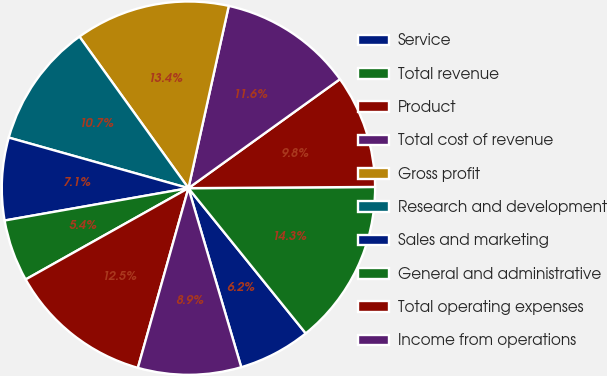Convert chart. <chart><loc_0><loc_0><loc_500><loc_500><pie_chart><fcel>Service<fcel>Total revenue<fcel>Product<fcel>Total cost of revenue<fcel>Gross profit<fcel>Research and development<fcel>Sales and marketing<fcel>General and administrative<fcel>Total operating expenses<fcel>Income from operations<nl><fcel>6.25%<fcel>14.29%<fcel>9.82%<fcel>11.61%<fcel>13.39%<fcel>10.71%<fcel>7.14%<fcel>5.36%<fcel>12.5%<fcel>8.93%<nl></chart> 